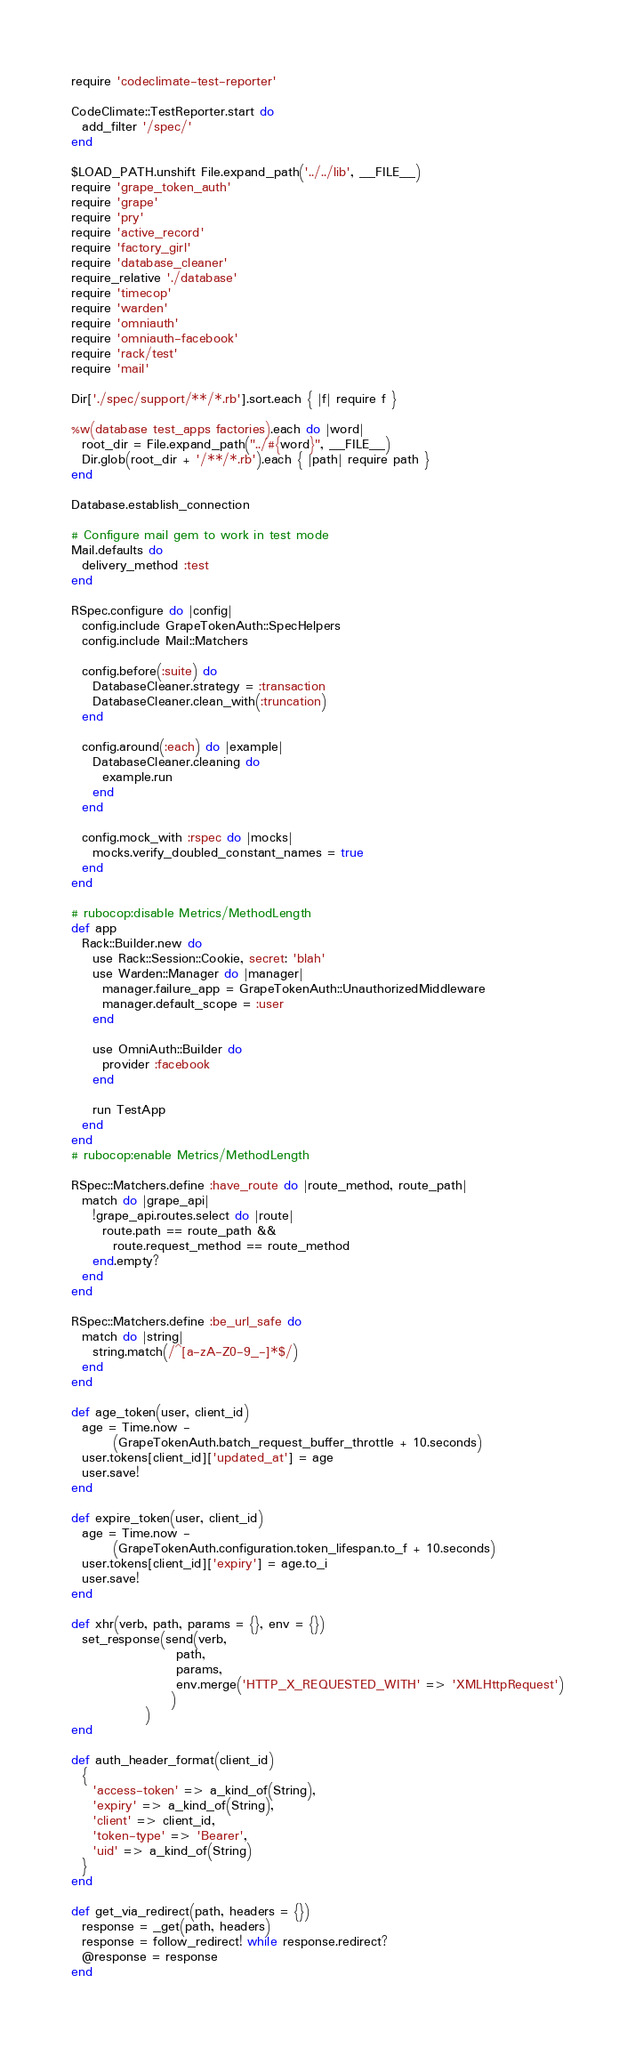<code> <loc_0><loc_0><loc_500><loc_500><_Ruby_>require 'codeclimate-test-reporter'

CodeClimate::TestReporter.start do
  add_filter '/spec/'
end

$LOAD_PATH.unshift File.expand_path('../../lib', __FILE__)
require 'grape_token_auth'
require 'grape'
require 'pry'
require 'active_record'
require 'factory_girl'
require 'database_cleaner'
require_relative './database'
require 'timecop'
require 'warden'
require 'omniauth'
require 'omniauth-facebook'
require 'rack/test'
require 'mail'

Dir['./spec/support/**/*.rb'].sort.each { |f| require f }

%w(database test_apps factories).each do |word|
  root_dir = File.expand_path("../#{word}", __FILE__)
  Dir.glob(root_dir + '/**/*.rb').each { |path| require path }
end

Database.establish_connection

# Configure mail gem to work in test mode
Mail.defaults do
  delivery_method :test
end

RSpec.configure do |config|
  config.include GrapeTokenAuth::SpecHelpers
  config.include Mail::Matchers

  config.before(:suite) do
    DatabaseCleaner.strategy = :transaction
    DatabaseCleaner.clean_with(:truncation)
  end

  config.around(:each) do |example|
    DatabaseCleaner.cleaning do
      example.run
    end
  end

  config.mock_with :rspec do |mocks|
    mocks.verify_doubled_constant_names = true
  end
end

# rubocop:disable Metrics/MethodLength
def app
  Rack::Builder.new do
    use Rack::Session::Cookie, secret: 'blah'
    use Warden::Manager do |manager|
      manager.failure_app = GrapeTokenAuth::UnauthorizedMiddleware
      manager.default_scope = :user
    end

    use OmniAuth::Builder do
      provider :facebook
    end

    run TestApp
  end
end
# rubocop:enable Metrics/MethodLength

RSpec::Matchers.define :have_route do |route_method, route_path|
  match do |grape_api|
    !grape_api.routes.select do |route|
      route.path == route_path &&
        route.request_method == route_method
    end.empty?
  end
end

RSpec::Matchers.define :be_url_safe do
  match do |string|
    string.match(/^[a-zA-Z0-9_-]*$/)
  end
end

def age_token(user, client_id)
  age = Time.now -
        (GrapeTokenAuth.batch_request_buffer_throttle + 10.seconds)
  user.tokens[client_id]['updated_at'] = age
  user.save!
end

def expire_token(user, client_id)
  age = Time.now -
        (GrapeTokenAuth.configuration.token_lifespan.to_f + 10.seconds)
  user.tokens[client_id]['expiry'] = age.to_i
  user.save!
end

def xhr(verb, path, params = {}, env = {})
  set_response(send(verb,
                    path,
                    params,
                    env.merge('HTTP_X_REQUESTED_WITH' => 'XMLHttpRequest')
                   )
              )
end

def auth_header_format(client_id)
  {
    'access-token' => a_kind_of(String),
    'expiry' => a_kind_of(String),
    'client' => client_id,
    'token-type' => 'Bearer',
    'uid' => a_kind_of(String)
  }
end

def get_via_redirect(path, headers = {})
  response = _get(path, headers)
  response = follow_redirect! while response.redirect?
  @response = response
end
</code> 